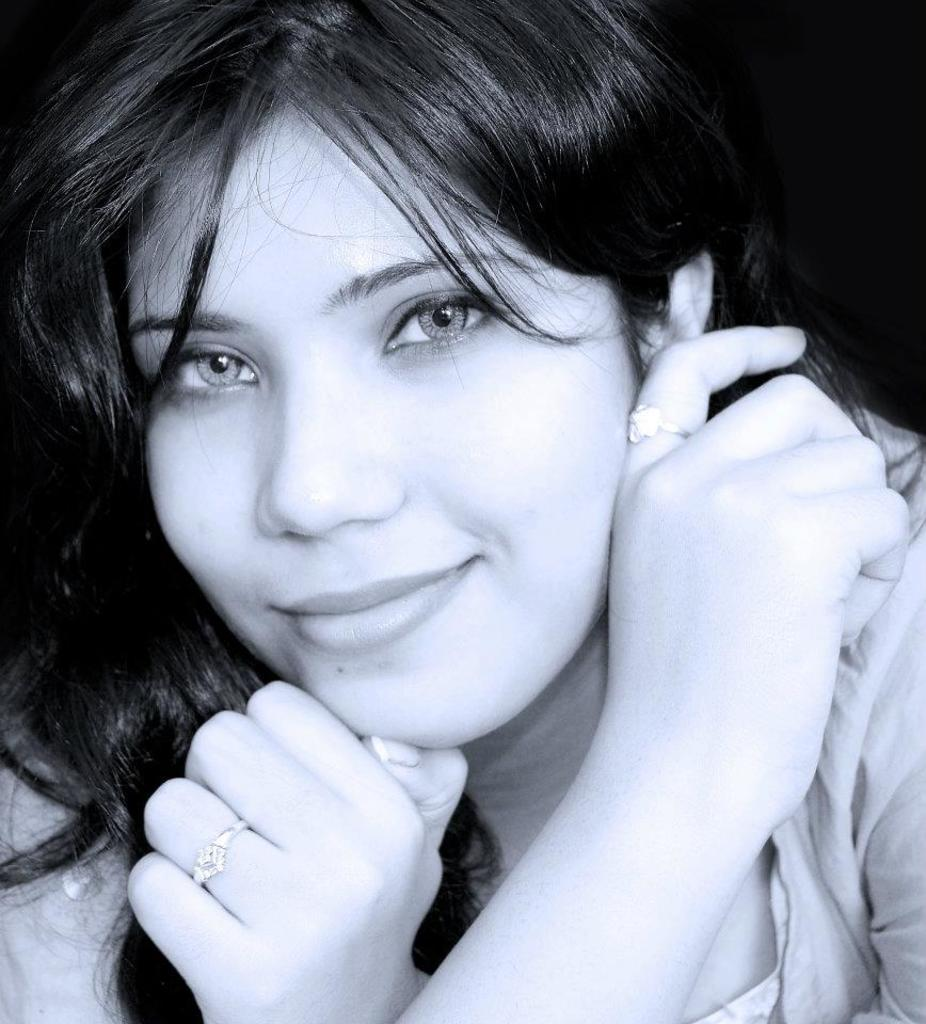What is the color scheme of the image? The image is black and white. Can you describe the main subject in the image? There is a woman in the image. What time is displayed on the clock in the image? There is no clock present in the image. What type of screw is being used by the woman in the image? There is no screw visible in the image. 